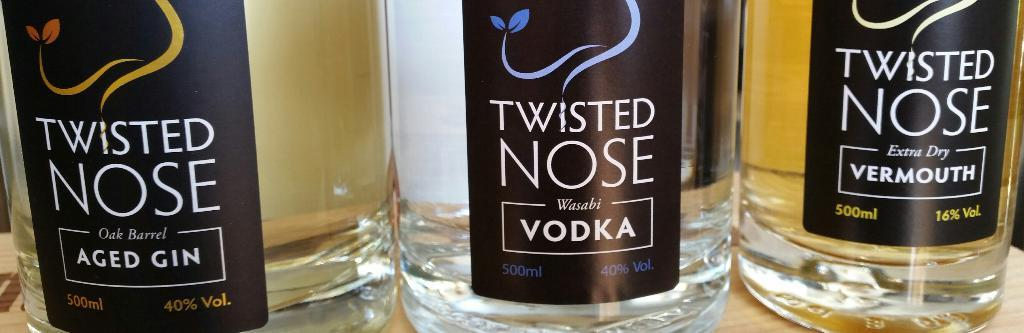<image>
Create a compact narrative representing the image presented. Bottles with black labels with one that says VODKA. 